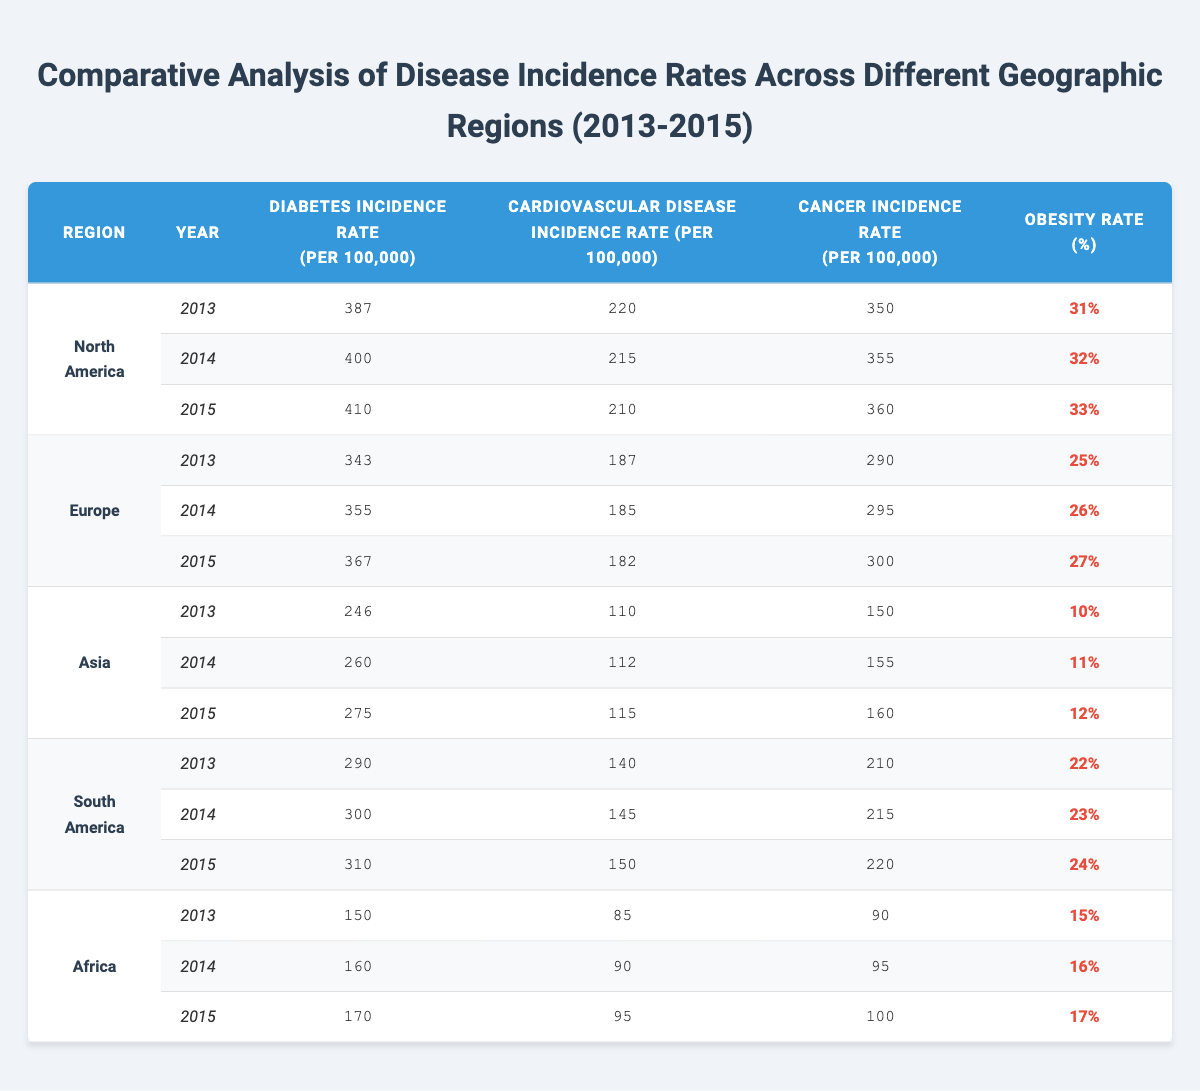What was the Diabetes Incidence Rate in North America in 2014? The table shows that in North America, the Diabetes Incidence Rate for the year 2014 is 400 per 100,000.
Answer: 400 What is the Cancer Incidence Rate for Asia in 2015? According to the table, the Cancer Incidence Rate in Asia for 2015 is 160 per 100,000.
Answer: 160 Which region had the highest Cardiovascular Disease Incidence Rate in 2013? Looking at the data for 2013, North America had the highest Cardiovascular Disease Incidence Rate at 220 per 100,000 compared to Europe (187), Asia (110), South America (140), and Africa (85).
Answer: North America What is the average Obesity Rate for Europe over the three years? To find the average, add the Obesity Rates for Europe: 25% + 26% + 27% = 78%. Then divide by 3 to get an average of 78% / 3 = 26%.
Answer: 26% Is the Diabetes Incidence Rate increasing in South America from 2013 to 2015? Yes, in South America, the Diabetes Incidence Rate increased from 290 in 2013 to 310 in 2015, showing a consistent rise over the years.
Answer: Yes What is the difference in Cancer Incidence Rate between North America and Africa in 2015? In 2015, North America's Cancer Incidence Rate was 360, while Africa's was 100. The difference is 360 - 100 = 260.
Answer: 260 Which region had the lowest Obesity Rate in the table? The table shows that Asia had the lowest Obesity Rate at 10% in 2013.
Answer: Asia What was the total Diabetes Incidence Rate for all regions combined in 2014? In 2014, the total Diabetes Incidence Rate is calculated as follows: North America (400) + Europe (355) + Asia (260) + South America (300) + Africa (160) = 1475 per 100,000.
Answer: 1475 Did the Cardiovascular Disease Incidence Rate ever exceed 200 in Europe during the years presented? No, the highest Cardiovascular Disease Incidence Rate in Europe was 187 in 2013, which did not exceed 200.
Answer: No Calculate the average Diabetes Incidence Rate for Africa over the three years. For Africa, the Diabetes Incidence Rates are 150, 160, and 170. The total is 150 + 160 + 170 = 480, and the average is 480 / 3 = 160.
Answer: 160 What trend do you see for the Cardiovascular Disease Incidence Rate in North America from 2013 to 2015? The trend shows a decrease in the Cardiovascular Disease Incidence Rate from 220 in 2013 to 210 in 2015.
Answer: Decrease 